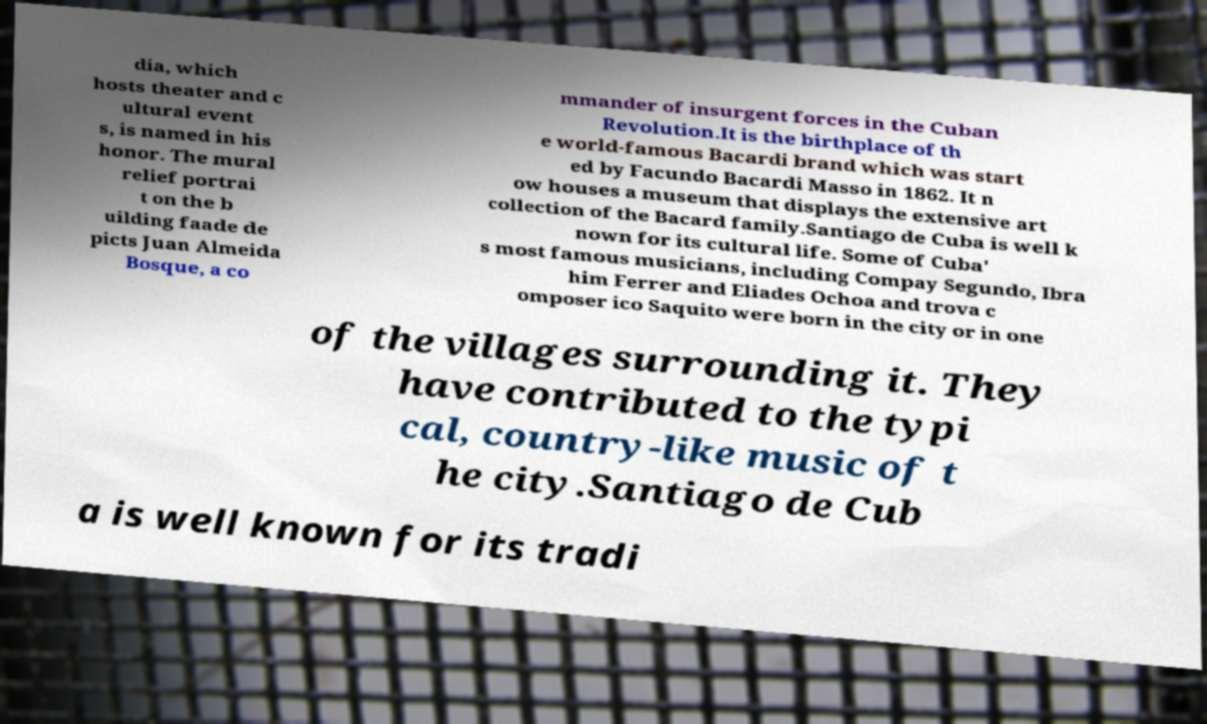Can you read and provide the text displayed in the image?This photo seems to have some interesting text. Can you extract and type it out for me? dia, which hosts theater and c ultural event s, is named in his honor. The mural relief portrai t on the b uilding faade de picts Juan Almeida Bosque, a co mmander of insurgent forces in the Cuban Revolution.It is the birthplace of th e world-famous Bacardi brand which was start ed by Facundo Bacardi Masso in 1862. It n ow houses a museum that displays the extensive art collection of the Bacard family.Santiago de Cuba is well k nown for its cultural life. Some of Cuba' s most famous musicians, including Compay Segundo, Ibra him Ferrer and Eliades Ochoa and trova c omposer ico Saquito were born in the city or in one of the villages surrounding it. They have contributed to the typi cal, country-like music of t he city.Santiago de Cub a is well known for its tradi 